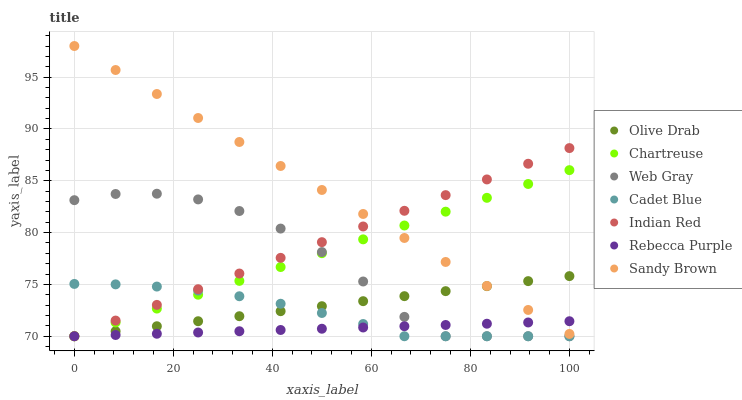Does Rebecca Purple have the minimum area under the curve?
Answer yes or no. Yes. Does Sandy Brown have the maximum area under the curve?
Answer yes or no. Yes. Does Chartreuse have the minimum area under the curve?
Answer yes or no. No. Does Chartreuse have the maximum area under the curve?
Answer yes or no. No. Is Sandy Brown the smoothest?
Answer yes or no. Yes. Is Web Gray the roughest?
Answer yes or no. Yes. Is Chartreuse the smoothest?
Answer yes or no. No. Is Chartreuse the roughest?
Answer yes or no. No. Does Cadet Blue have the lowest value?
Answer yes or no. Yes. Does Sandy Brown have the lowest value?
Answer yes or no. No. Does Sandy Brown have the highest value?
Answer yes or no. Yes. Does Chartreuse have the highest value?
Answer yes or no. No. Is Cadet Blue less than Sandy Brown?
Answer yes or no. Yes. Is Sandy Brown greater than Web Gray?
Answer yes or no. Yes. Does Sandy Brown intersect Indian Red?
Answer yes or no. Yes. Is Sandy Brown less than Indian Red?
Answer yes or no. No. Is Sandy Brown greater than Indian Red?
Answer yes or no. No. Does Cadet Blue intersect Sandy Brown?
Answer yes or no. No. 